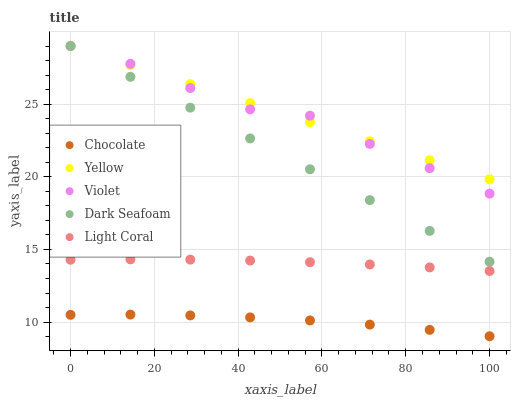Does Chocolate have the minimum area under the curve?
Answer yes or no. Yes. Does Yellow have the maximum area under the curve?
Answer yes or no. Yes. Does Dark Seafoam have the minimum area under the curve?
Answer yes or no. No. Does Dark Seafoam have the maximum area under the curve?
Answer yes or no. No. Is Yellow the smoothest?
Answer yes or no. Yes. Is Violet the roughest?
Answer yes or no. Yes. Is Dark Seafoam the smoothest?
Answer yes or no. No. Is Dark Seafoam the roughest?
Answer yes or no. No. Does Chocolate have the lowest value?
Answer yes or no. Yes. Does Dark Seafoam have the lowest value?
Answer yes or no. No. Does Yellow have the highest value?
Answer yes or no. Yes. Does Chocolate have the highest value?
Answer yes or no. No. Is Chocolate less than Dark Seafoam?
Answer yes or no. Yes. Is Yellow greater than Chocolate?
Answer yes or no. Yes. Does Yellow intersect Violet?
Answer yes or no. Yes. Is Yellow less than Violet?
Answer yes or no. No. Is Yellow greater than Violet?
Answer yes or no. No. Does Chocolate intersect Dark Seafoam?
Answer yes or no. No. 